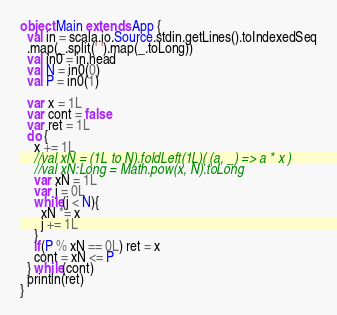<code> <loc_0><loc_0><loc_500><loc_500><_Scala_>object Main extends App {
  val in = scala.io.Source.stdin.getLines().toIndexedSeq
  .map(_.split(' ').map(_.toLong))
  val in0 = in.head
  val N = in0(0)
  val P = in0(1)
  
  var x = 1L
  var cont = false
  var ret = 1L
  do {
    x += 1L
    //val xN = (1L to N).foldLeft(1L)( (a, _) => a * x )
    //val xN:Long = Math.pow(x, N).toLong
    var xN = 1L
    var j = 0L
    while(j < N){
      xN *= x
      j += 1L
    }
    if(P % xN == 0L) ret = x
    cont = xN <= P
  } while(cont)
  println(ret)
}
</code> 